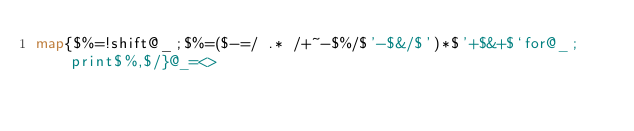Convert code to text. <code><loc_0><loc_0><loc_500><loc_500><_Perl_>map{$%=!shift@_;$%=($-=/ .* /+~-$%/$'-$&/$')*$'+$&+$`for@_;print$%,$/}@_=<></code> 